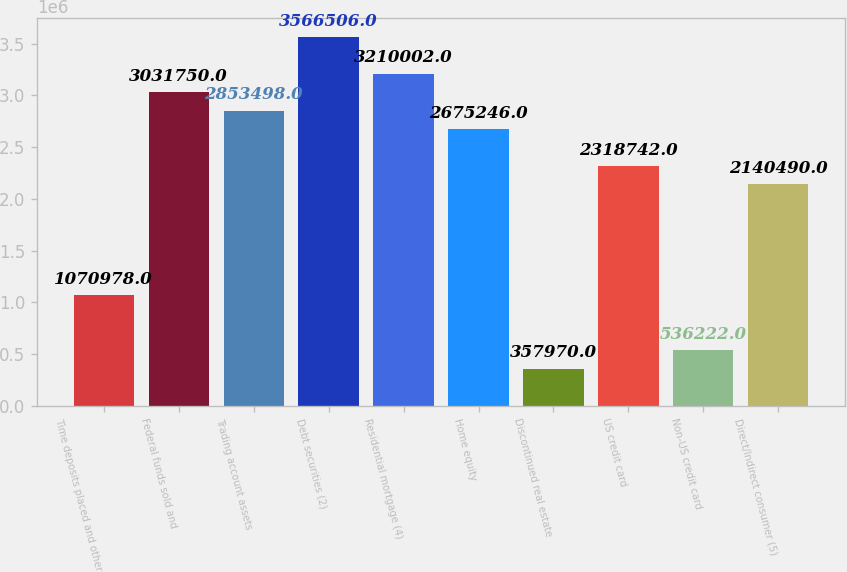Convert chart to OTSL. <chart><loc_0><loc_0><loc_500><loc_500><bar_chart><fcel>Time deposits placed and other<fcel>Federal funds sold and<fcel>Trading account assets<fcel>Debt securities (2)<fcel>Residential mortgage (4)<fcel>Home equity<fcel>Discontinued real estate<fcel>US credit card<fcel>Non-US credit card<fcel>Direct/Indirect consumer (5)<nl><fcel>1.07098e+06<fcel>3.03175e+06<fcel>2.8535e+06<fcel>3.56651e+06<fcel>3.21e+06<fcel>2.67525e+06<fcel>357970<fcel>2.31874e+06<fcel>536222<fcel>2.14049e+06<nl></chart> 